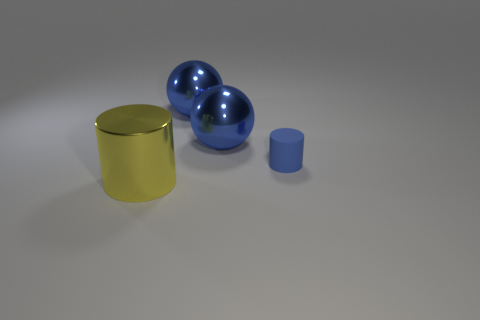Is there a large cyan matte thing of the same shape as the yellow metallic thing?
Keep it short and to the point. No. There is a metallic cylinder; is it the same size as the cylinder behind the yellow cylinder?
Ensure brevity in your answer.  No. How many objects are big shiny things behind the yellow thing or cylinders to the right of the big yellow cylinder?
Provide a short and direct response. 3. Are there more large cylinders that are on the right side of the small blue cylinder than cylinders?
Your answer should be very brief. No. How many blue things have the same size as the yellow thing?
Your answer should be very brief. 2. Do the cylinder to the left of the tiny blue cylinder and the cylinder that is behind the large cylinder have the same size?
Offer a very short reply. No. What size is the thing that is in front of the tiny blue object?
Provide a succinct answer. Large. There is a cylinder that is right of the cylinder in front of the blue rubber thing; how big is it?
Provide a succinct answer. Small. Are there any big yellow metallic cylinders left of the large yellow thing?
Offer a very short reply. No. Are there the same number of things that are in front of the blue cylinder and blue cylinders?
Provide a short and direct response. Yes. 